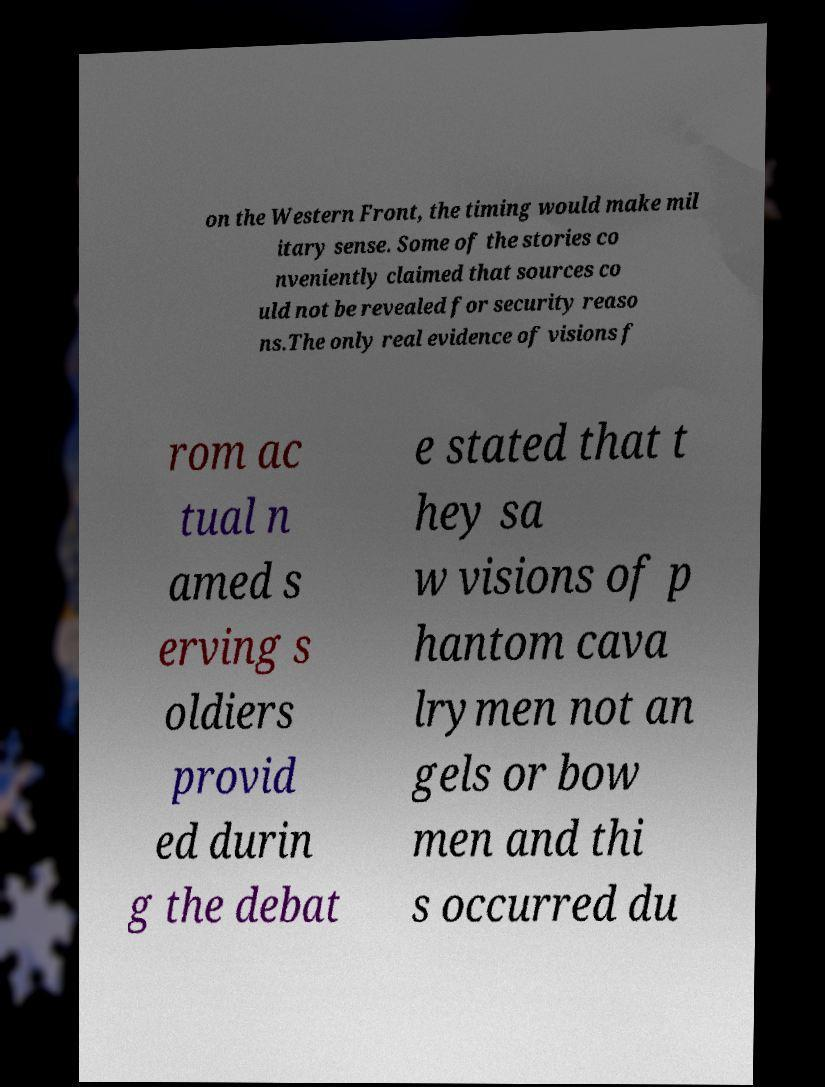Please identify and transcribe the text found in this image. on the Western Front, the timing would make mil itary sense. Some of the stories co nveniently claimed that sources co uld not be revealed for security reaso ns.The only real evidence of visions f rom ac tual n amed s erving s oldiers provid ed durin g the debat e stated that t hey sa w visions of p hantom cava lrymen not an gels or bow men and thi s occurred du 